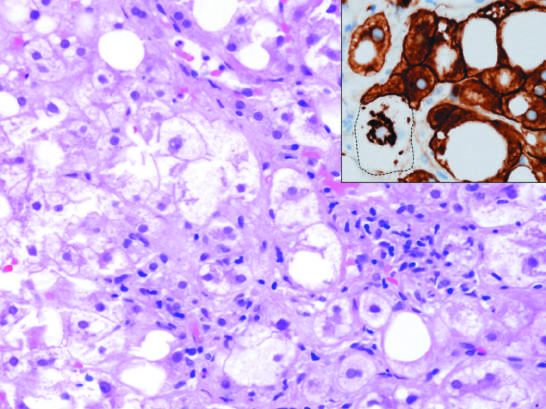how is hepatocyte injury in fatty liver disease associated?
Answer the question using a single word or phrase. With chronic alcohol use 